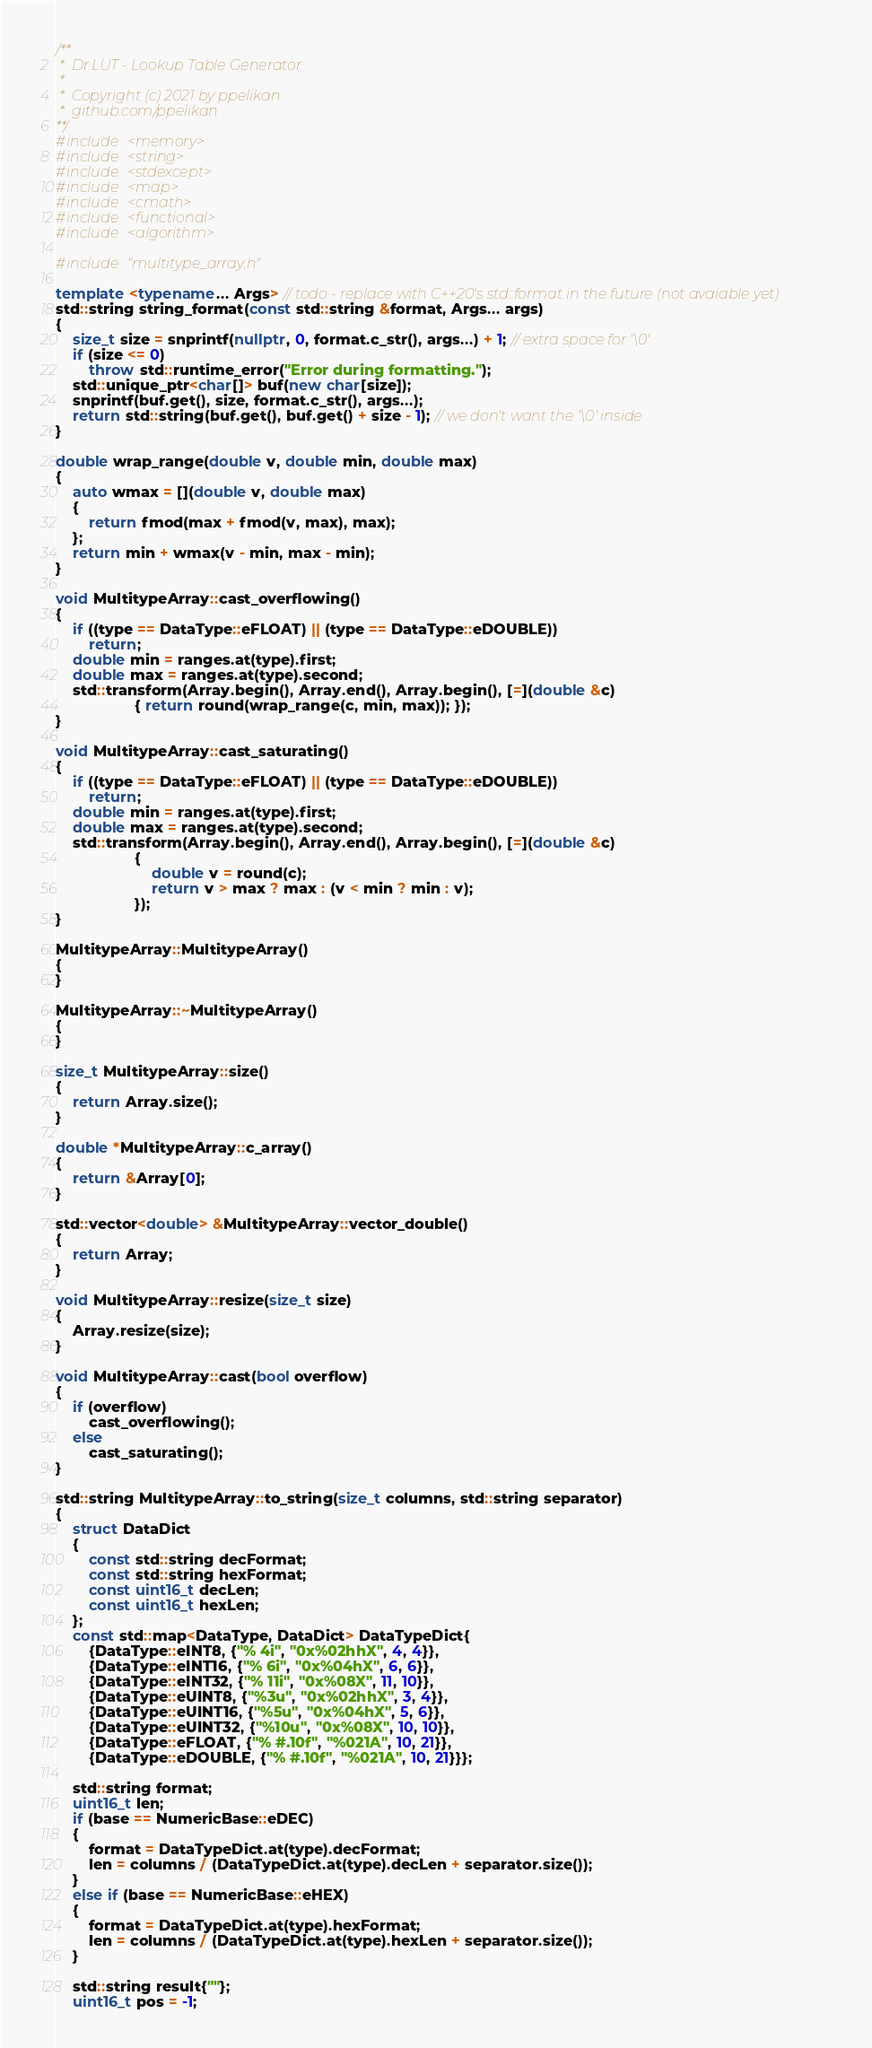Convert code to text. <code><loc_0><loc_0><loc_500><loc_500><_C++_>/**
 *  Dr.LUT - Lookup Table Generator
 * 
 *  Copyright (c) 2021 by ppelikan
 *  github.com/ppelikan
**/
#include <memory>
#include <string>
#include <stdexcept>
#include <map>
#include <cmath>
#include <functional>
#include <algorithm>

#include "multitype_array.h"

template <typename... Args> // todo - replace with C++20's std::format in the future (not avaiable yet)
std::string string_format(const std::string &format, Args... args)
{
    size_t size = snprintf(nullptr, 0, format.c_str(), args...) + 1; // extra space for '\0'
    if (size <= 0)
        throw std::runtime_error("Error during formatting.");
    std::unique_ptr<char[]> buf(new char[size]);
    snprintf(buf.get(), size, format.c_str(), args...);
    return std::string(buf.get(), buf.get() + size - 1); // we don't want the '\0' inside
}

double wrap_range(double v, double min, double max)
{
    auto wmax = [](double v, double max)
    {
        return fmod(max + fmod(v, max), max);
    };
    return min + wmax(v - min, max - min);
}

void MultitypeArray::cast_overflowing()
{
    if ((type == DataType::eFLOAT) || (type == DataType::eDOUBLE))
        return;
    double min = ranges.at(type).first;
    double max = ranges.at(type).second;
    std::transform(Array.begin(), Array.end(), Array.begin(), [=](double &c)
                   { return round(wrap_range(c, min, max)); });
}

void MultitypeArray::cast_saturating()
{
    if ((type == DataType::eFLOAT) || (type == DataType::eDOUBLE))
        return;
    double min = ranges.at(type).first;
    double max = ranges.at(type).second;
    std::transform(Array.begin(), Array.end(), Array.begin(), [=](double &c)
                   {
                       double v = round(c);
                       return v > max ? max : (v < min ? min : v);
                   });
}

MultitypeArray::MultitypeArray()
{
}

MultitypeArray::~MultitypeArray()
{
}

size_t MultitypeArray::size()
{
    return Array.size();
}

double *MultitypeArray::c_array()
{
    return &Array[0];
}

std::vector<double> &MultitypeArray::vector_double()
{
    return Array;
}

void MultitypeArray::resize(size_t size)
{
    Array.resize(size);
}

void MultitypeArray::cast(bool overflow)
{
    if (overflow)
        cast_overflowing();
    else
        cast_saturating();
}

std::string MultitypeArray::to_string(size_t columns, std::string separator)
{
    struct DataDict
    {
        const std::string decFormat;
        const std::string hexFormat;
        const uint16_t decLen;
        const uint16_t hexLen;
    };
    const std::map<DataType, DataDict> DataTypeDict{
        {DataType::eINT8, {"% 4i", "0x%02hhX", 4, 4}},
        {DataType::eINT16, {"% 6i", "0x%04hX", 6, 6}},
        {DataType::eINT32, {"% 11i", "0x%08X", 11, 10}},
        {DataType::eUINT8, {"%3u", "0x%02hhX", 3, 4}},
        {DataType::eUINT16, {"%5u", "0x%04hX", 5, 6}},
        {DataType::eUINT32, {"%10u", "0x%08X", 10, 10}},
        {DataType::eFLOAT, {"% #.10f", "%021A", 10, 21}},
        {DataType::eDOUBLE, {"% #.10f", "%021A", 10, 21}}};

    std::string format;
    uint16_t len;
    if (base == NumericBase::eDEC)
    {
        format = DataTypeDict.at(type).decFormat;
        len = columns / (DataTypeDict.at(type).decLen + separator.size());
    }
    else if (base == NumericBase::eHEX)
    {
        format = DataTypeDict.at(type).hexFormat;
        len = columns / (DataTypeDict.at(type).hexLen + separator.size());
    }

    std::string result{""};
    uint16_t pos = -1;</code> 